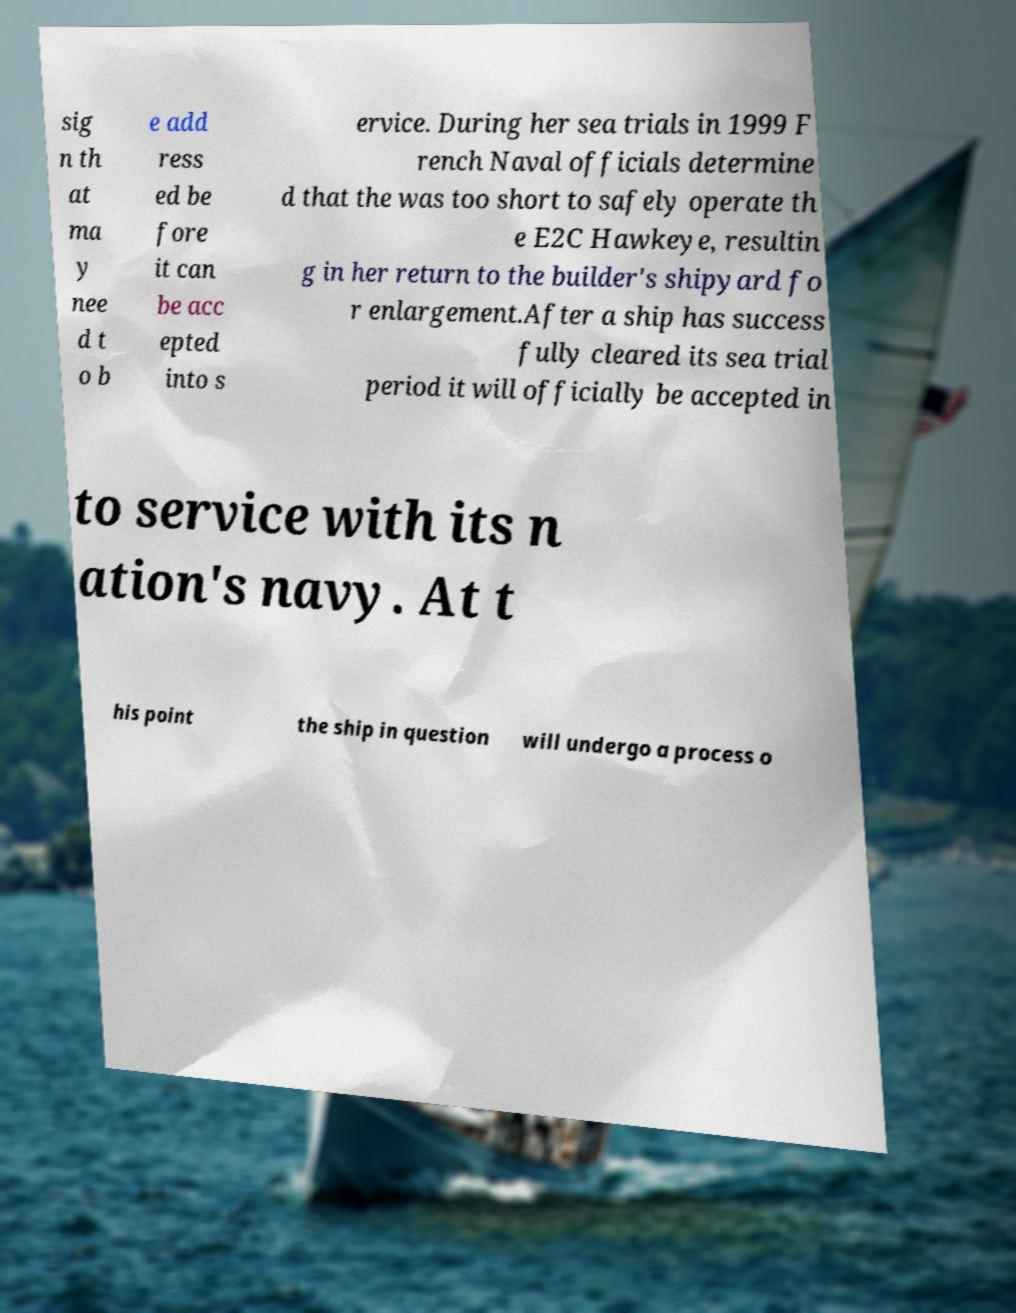I need the written content from this picture converted into text. Can you do that? sig n th at ma y nee d t o b e add ress ed be fore it can be acc epted into s ervice. During her sea trials in 1999 F rench Naval officials determine d that the was too short to safely operate th e E2C Hawkeye, resultin g in her return to the builder's shipyard fo r enlargement.After a ship has success fully cleared its sea trial period it will officially be accepted in to service with its n ation's navy. At t his point the ship in question will undergo a process o 